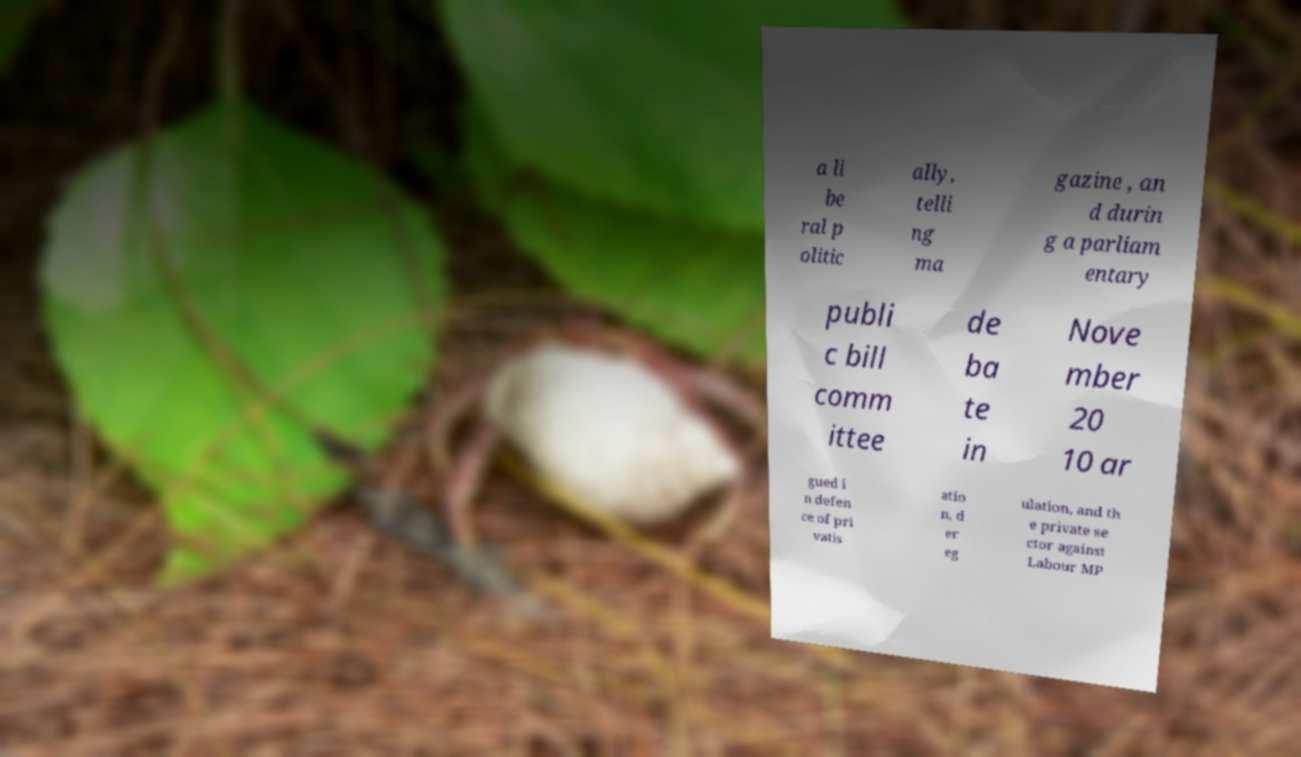Could you extract and type out the text from this image? a li be ral p olitic ally, telli ng ma gazine , an d durin g a parliam entary publi c bill comm ittee de ba te in Nove mber 20 10 ar gued i n defen ce of pri vatis atio n, d er eg ulation, and th e private se ctor against Labour MP 